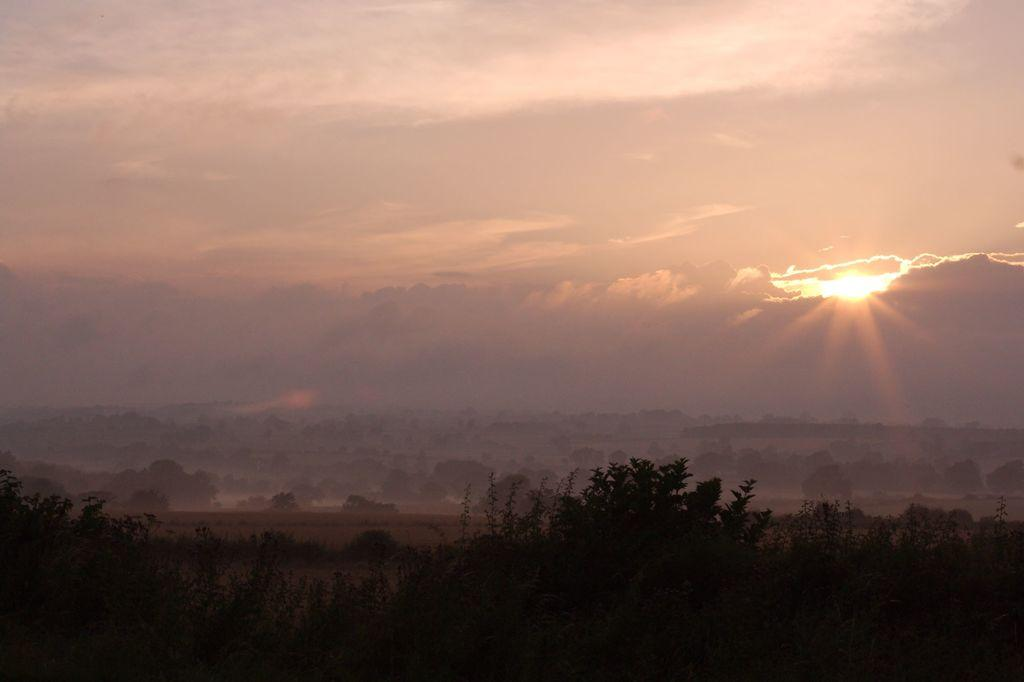What type of vegetation can be seen in the image? There is a group of trees in the image. What celestial body is visible in the sky on the right side of the image? The sun is visible in the sky on the right side of the image. What type of war is being fought in the image? There is no war present in the image; it features a group of trees and the sun in the sky. What occupation does the self-portrait in the image depict? There is no self-portrait or carpenter present in the image. 